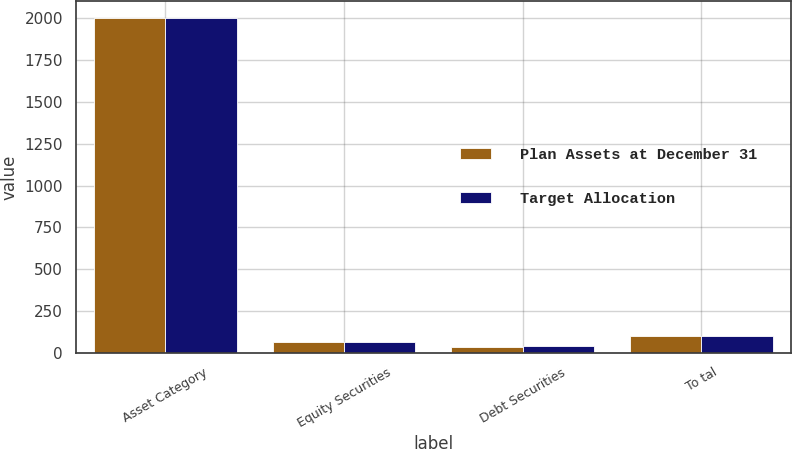<chart> <loc_0><loc_0><loc_500><loc_500><stacked_bar_chart><ecel><fcel>Asset Category<fcel>Equity Securities<fcel>Debt Securities<fcel>To tal<nl><fcel>Plan Assets at December 31<fcel>2004<fcel>65<fcel>35<fcel>100<nl><fcel>Target Allocation<fcel>2003<fcel>62<fcel>38<fcel>100<nl></chart> 